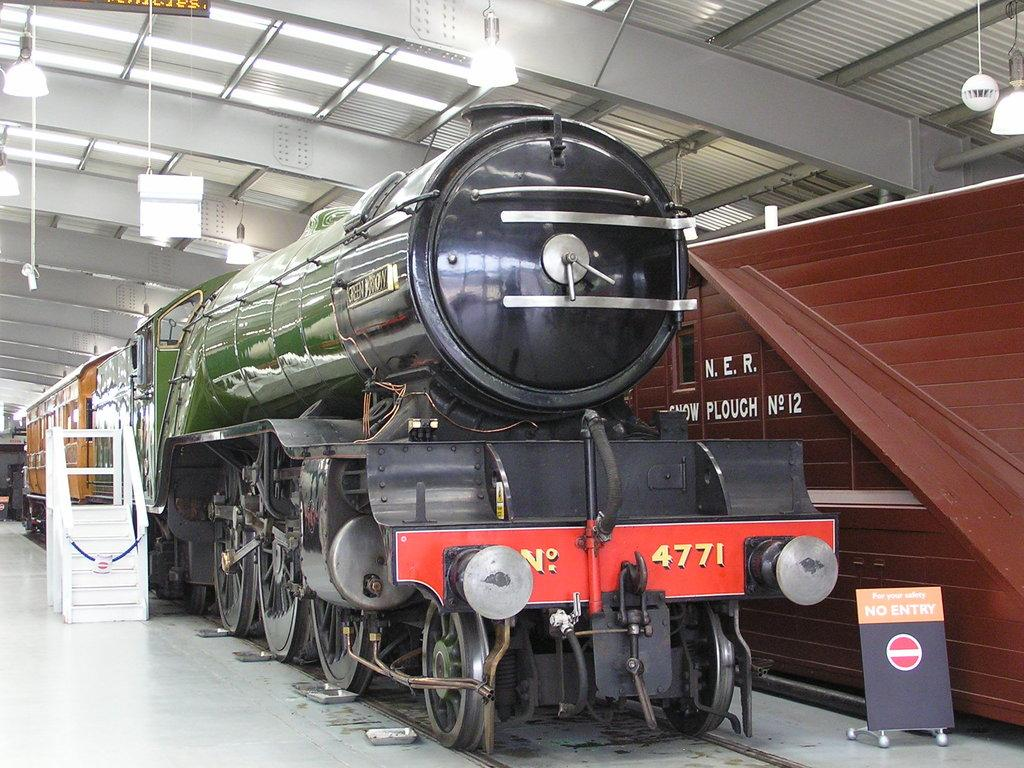What is the main subject of the image? There is a train in the image. Where is the train located? The train is on a railway track. What else can be seen in the image besides the train? There is a board, stars, lights, and other objects visible in the image. What month is it in the image? The month is not mentioned or depicted in the image, so it cannot be determined. How many chickens are present in the image? There are no chickens present in the image. 